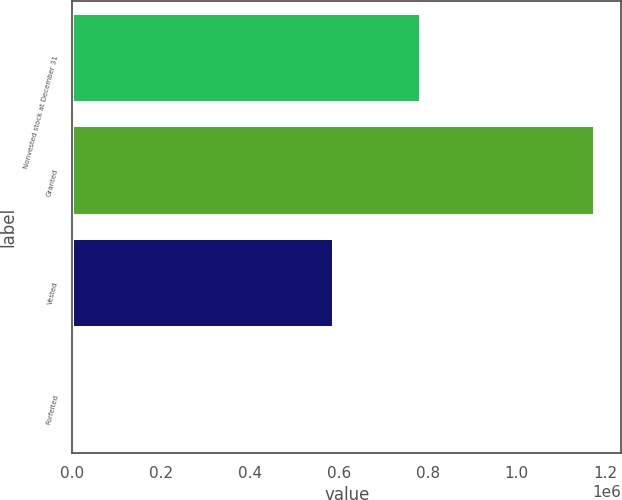Convert chart. <chart><loc_0><loc_0><loc_500><loc_500><bar_chart><fcel>Nonvested stock at December 31<fcel>Granted<fcel>Vested<fcel>Forfeited<nl><fcel>785176<fcel>1.17703e+06<fcel>589229<fcel>5506<nl></chart> 